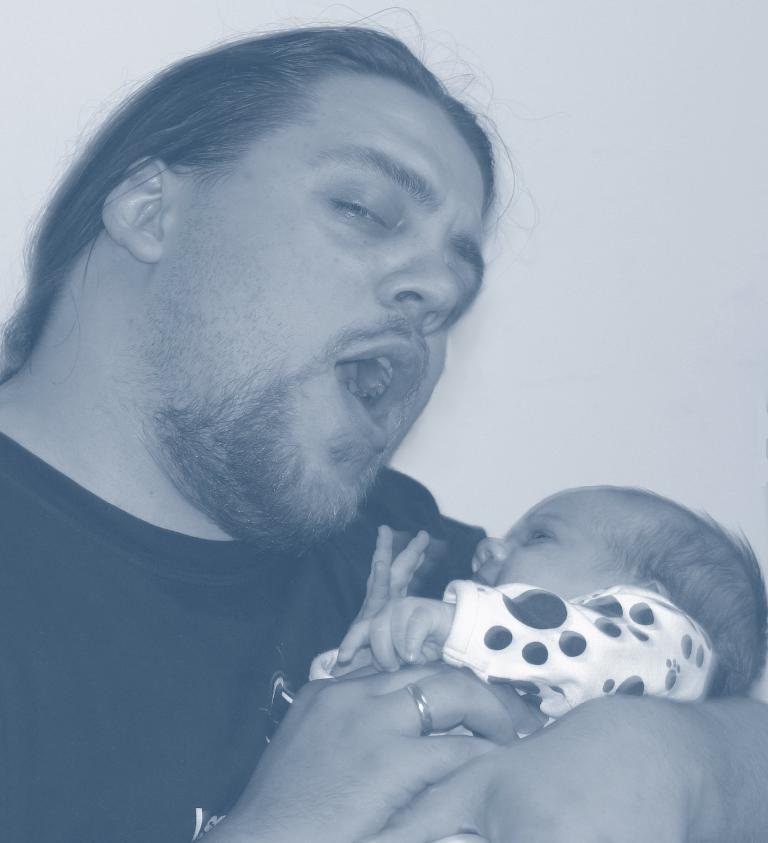What is happening on the left side of the image? There is a person on the left side of the image, and they are speaking. What is the person holding in the image? The person is holding a baby with both hands. What is the color of the background in the image? The background of the image is white in color. What type of goldfish can be seen swimming in the background of the image? There are no goldfish present in the image; the background is white in color. 